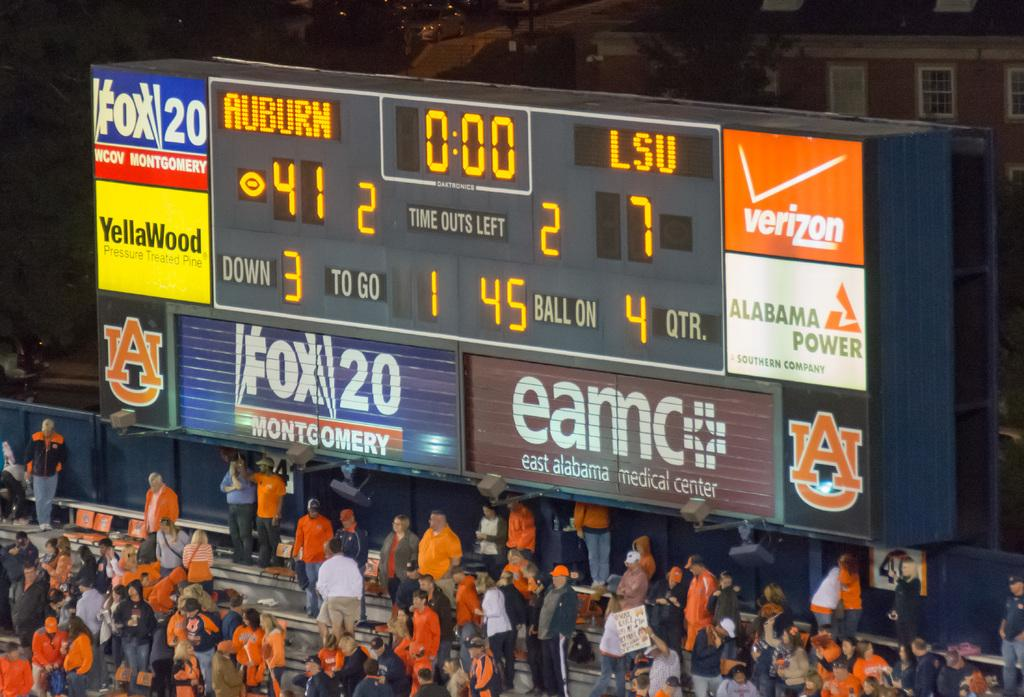<image>
Give a short and clear explanation of the subsequent image. The scoreboard for a game between auburn and LSU with ads for fox and verizon. 